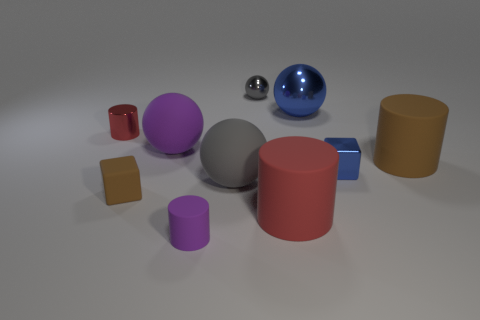There is a large brown thing that is the same shape as the red shiny thing; what material is it?
Give a very brief answer. Rubber. Is there any other thing that is the same size as the purple rubber cylinder?
Keep it short and to the point. Yes. Are there any small matte cylinders?
Your answer should be compact. Yes. The cylinder on the left side of the purple thing that is in front of the sphere to the left of the small matte cylinder is made of what material?
Your response must be concise. Metal. Is the shape of the big blue shiny thing the same as the purple matte thing right of the big purple rubber sphere?
Offer a terse response. No. How many big blue matte objects have the same shape as the small purple matte object?
Provide a short and direct response. 0. What is the shape of the red shiny thing?
Offer a terse response. Cylinder. How big is the brown thing left of the gray ball that is in front of the tiny ball?
Make the answer very short. Small. How many things are either large purple objects or rubber objects?
Provide a short and direct response. 6. Do the big blue object and the small purple thing have the same shape?
Give a very brief answer. No. 